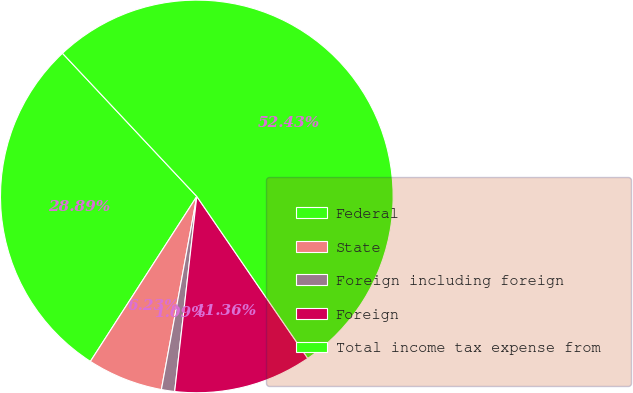<chart> <loc_0><loc_0><loc_500><loc_500><pie_chart><fcel>Federal<fcel>State<fcel>Foreign including foreign<fcel>Foreign<fcel>Total income tax expense from<nl><fcel>28.89%<fcel>6.23%<fcel>1.09%<fcel>11.36%<fcel>52.43%<nl></chart> 